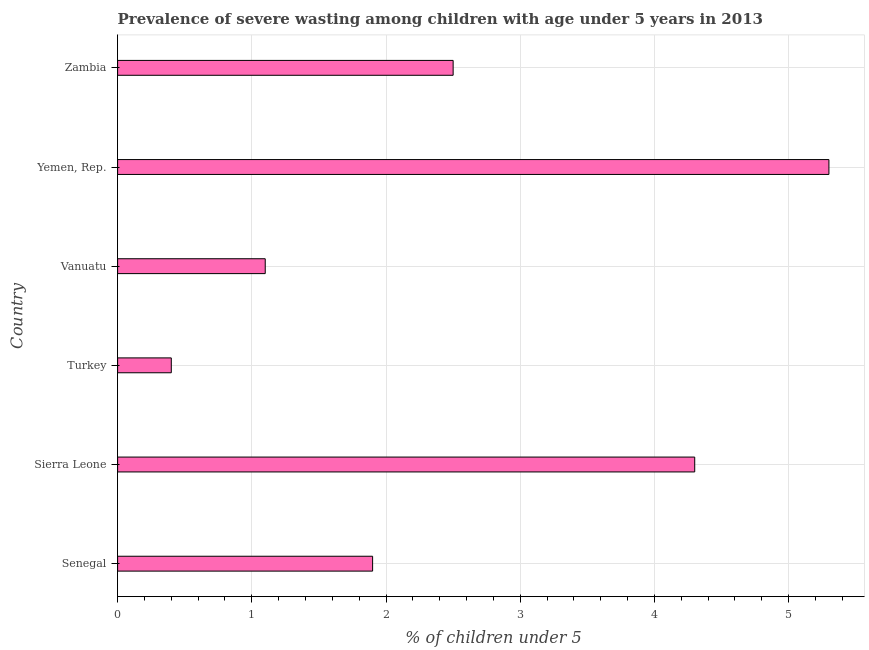Does the graph contain any zero values?
Offer a very short reply. No. Does the graph contain grids?
Provide a succinct answer. Yes. What is the title of the graph?
Offer a very short reply. Prevalence of severe wasting among children with age under 5 years in 2013. What is the label or title of the X-axis?
Keep it short and to the point.  % of children under 5. What is the label or title of the Y-axis?
Provide a short and direct response. Country. What is the prevalence of severe wasting in Turkey?
Your answer should be compact. 0.4. Across all countries, what is the maximum prevalence of severe wasting?
Your answer should be compact. 5.3. Across all countries, what is the minimum prevalence of severe wasting?
Your response must be concise. 0.4. In which country was the prevalence of severe wasting maximum?
Provide a succinct answer. Yemen, Rep. What is the sum of the prevalence of severe wasting?
Ensure brevity in your answer.  15.5. What is the difference between the prevalence of severe wasting in Vanuatu and Yemen, Rep.?
Provide a succinct answer. -4.2. What is the average prevalence of severe wasting per country?
Provide a short and direct response. 2.58. What is the median prevalence of severe wasting?
Keep it short and to the point. 2.2. In how many countries, is the prevalence of severe wasting greater than 2.8 %?
Provide a succinct answer. 2. What is the ratio of the prevalence of severe wasting in Yemen, Rep. to that in Zambia?
Offer a terse response. 2.12. Is the prevalence of severe wasting in Senegal less than that in Vanuatu?
Your answer should be very brief. No. What is the difference between the highest and the second highest prevalence of severe wasting?
Your answer should be compact. 1. How many bars are there?
Offer a very short reply. 6. Are all the bars in the graph horizontal?
Keep it short and to the point. Yes. How many countries are there in the graph?
Give a very brief answer. 6. What is the difference between two consecutive major ticks on the X-axis?
Provide a succinct answer. 1. What is the  % of children under 5 of Senegal?
Your answer should be compact. 1.9. What is the  % of children under 5 of Sierra Leone?
Your response must be concise. 4.3. What is the  % of children under 5 of Turkey?
Your response must be concise. 0.4. What is the  % of children under 5 in Vanuatu?
Provide a succinct answer. 1.1. What is the  % of children under 5 in Yemen, Rep.?
Offer a terse response. 5.3. What is the difference between the  % of children under 5 in Senegal and Sierra Leone?
Keep it short and to the point. -2.4. What is the difference between the  % of children under 5 in Senegal and Yemen, Rep.?
Your answer should be compact. -3.4. What is the difference between the  % of children under 5 in Senegal and Zambia?
Offer a very short reply. -0.6. What is the difference between the  % of children under 5 in Sierra Leone and Vanuatu?
Offer a terse response. 3.2. What is the difference between the  % of children under 5 in Sierra Leone and Yemen, Rep.?
Make the answer very short. -1. What is the difference between the  % of children under 5 in Turkey and Zambia?
Ensure brevity in your answer.  -2.1. What is the difference between the  % of children under 5 in Vanuatu and Yemen, Rep.?
Provide a succinct answer. -4.2. What is the difference between the  % of children under 5 in Vanuatu and Zambia?
Your answer should be compact. -1.4. What is the ratio of the  % of children under 5 in Senegal to that in Sierra Leone?
Offer a terse response. 0.44. What is the ratio of the  % of children under 5 in Senegal to that in Turkey?
Provide a succinct answer. 4.75. What is the ratio of the  % of children under 5 in Senegal to that in Vanuatu?
Provide a short and direct response. 1.73. What is the ratio of the  % of children under 5 in Senegal to that in Yemen, Rep.?
Your answer should be very brief. 0.36. What is the ratio of the  % of children under 5 in Senegal to that in Zambia?
Offer a very short reply. 0.76. What is the ratio of the  % of children under 5 in Sierra Leone to that in Turkey?
Your response must be concise. 10.75. What is the ratio of the  % of children under 5 in Sierra Leone to that in Vanuatu?
Your answer should be compact. 3.91. What is the ratio of the  % of children under 5 in Sierra Leone to that in Yemen, Rep.?
Your answer should be compact. 0.81. What is the ratio of the  % of children under 5 in Sierra Leone to that in Zambia?
Your answer should be very brief. 1.72. What is the ratio of the  % of children under 5 in Turkey to that in Vanuatu?
Give a very brief answer. 0.36. What is the ratio of the  % of children under 5 in Turkey to that in Yemen, Rep.?
Ensure brevity in your answer.  0.07. What is the ratio of the  % of children under 5 in Turkey to that in Zambia?
Make the answer very short. 0.16. What is the ratio of the  % of children under 5 in Vanuatu to that in Yemen, Rep.?
Your answer should be very brief. 0.21. What is the ratio of the  % of children under 5 in Vanuatu to that in Zambia?
Offer a terse response. 0.44. What is the ratio of the  % of children under 5 in Yemen, Rep. to that in Zambia?
Your answer should be very brief. 2.12. 